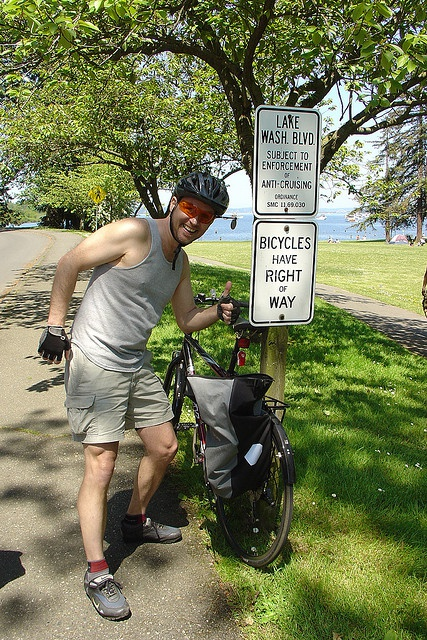Describe the objects in this image and their specific colors. I can see people in lightgreen, darkgray, gray, black, and ivory tones and bicycle in lightgreen, black, darkgreen, and gray tones in this image. 